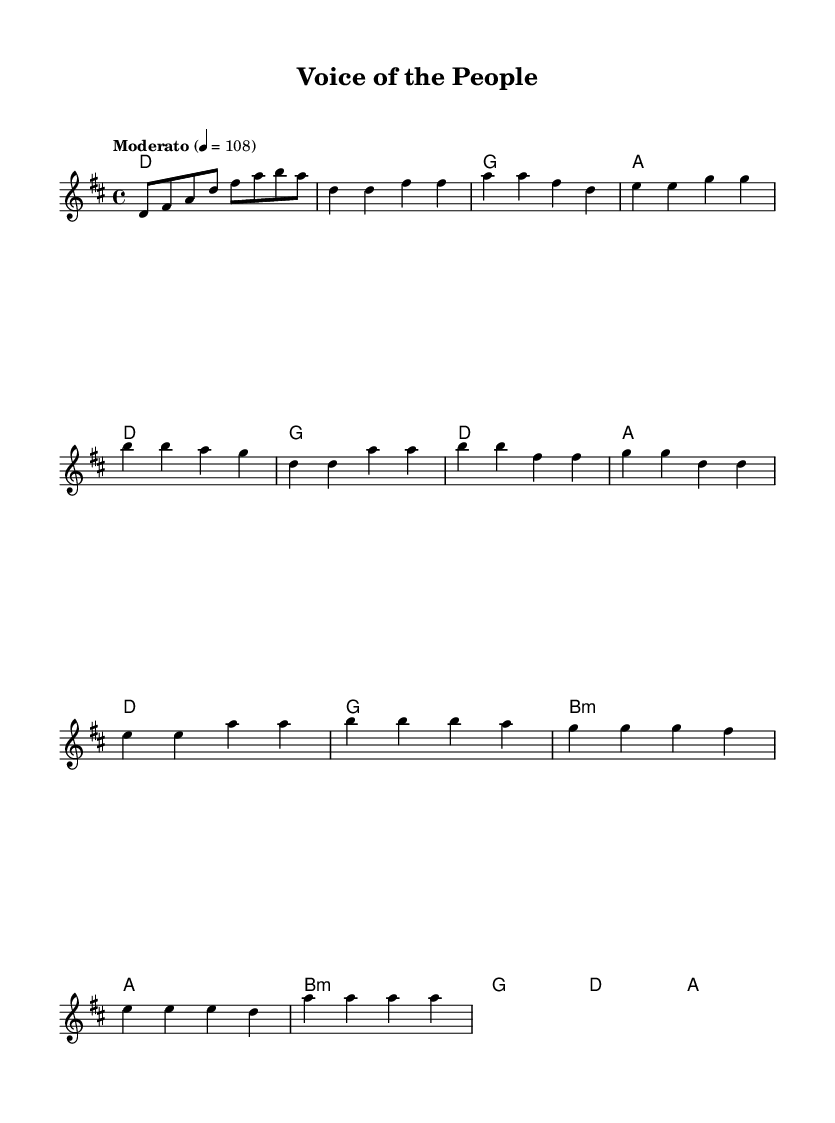What is the key signature of this music? The key signature is indicated by the number of sharps or flats written at the beginning of the staff. In this music, there are two sharps (F# and C#), so the key signature is D major.
Answer: D major What is the time signature of this music? The time signature is found at the beginning of the music, indicating how many beats are in each measure. Here, the time signature is 4/4, meaning there are four beats per measure, and the quarter note gets one beat.
Answer: 4/4 What is the tempo marking of this music? The tempo marking provides the speed of the music, typically shown at the beginning. In this sheet music, it says "Moderato" with a metronome indication of 4 = 108, which suggests a moderate speed.
Answer: Moderato How many sections does the music have? By analyzing the structure of the sheet music, we can see that it consists of an intro, verse, chorus, and bridge, making a total of four distinct sections.
Answer: Four What chords are used in the chorus? The chords of the chorus can be identified by looking at the chord names aligned with the melody. The chorus uses D, G, B minor, and A as its chords.
Answer: D, G, B minor, A Which note is the first note of the verse? The first note of the verse is located at the beginning of the verse section in the melody line. It is a D note, as indicated in the sheet music.
Answer: D What theme is explored in this music? The theme can often be inferred from the title, lyrics, or feel of the music. Here, the title "Voice of the People" suggests an exploration of political engagement and grassroots movements, which are common themes in folk music.
Answer: Political engagement 